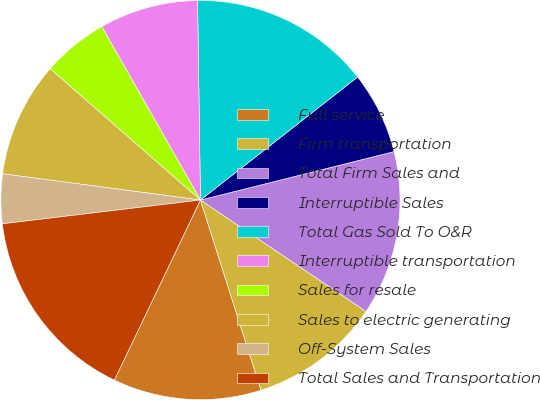Convert chart to OTSL. <chart><loc_0><loc_0><loc_500><loc_500><pie_chart><fcel>Full service<fcel>Firm transportation<fcel>Total Firm Sales and<fcel>Interruptible Sales<fcel>Total Gas Sold To O&R<fcel>Interruptible transportation<fcel>Sales for resale<fcel>Sales to electric generating<fcel>Off-System Sales<fcel>Total Sales and Transportation<nl><fcel>12.0%<fcel>10.67%<fcel>13.33%<fcel>6.67%<fcel>14.66%<fcel>8.0%<fcel>5.34%<fcel>9.33%<fcel>4.0%<fcel>16.0%<nl></chart> 